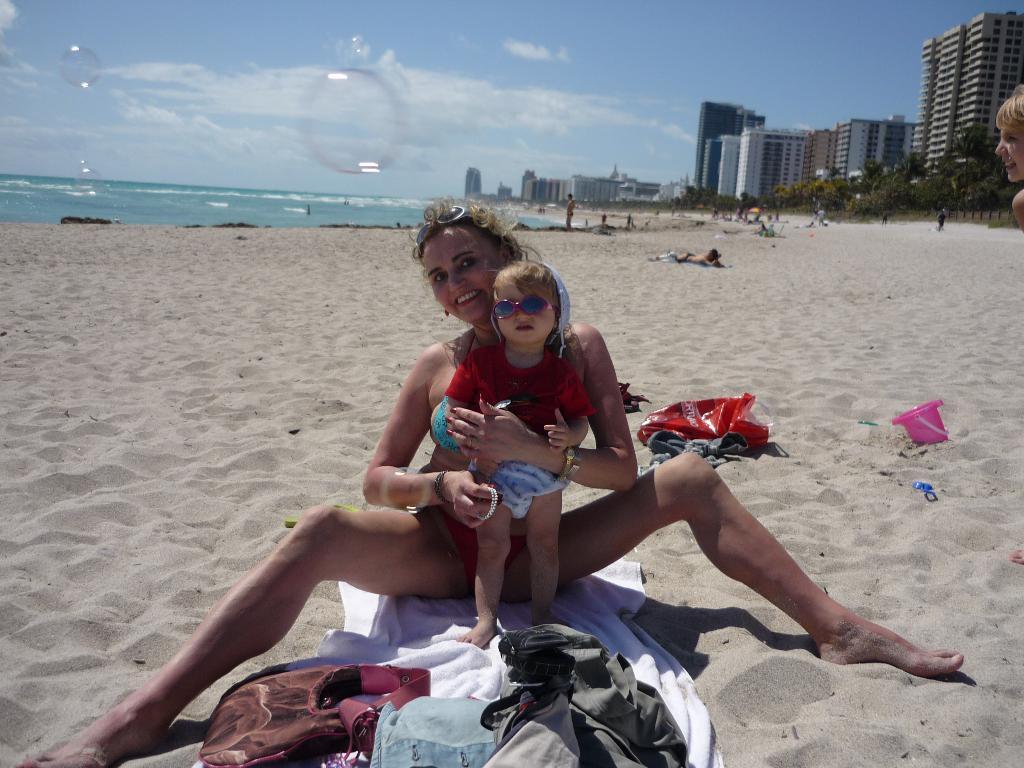How would you summarize this image in a sentence or two? Here we can see a woman sitting on a cloth and there is a kid standing on the cloth. Here we can see bags, bucket, and a plastic cover. In the background we can see water, buildings, trees, few persons, and sky with clouds. 